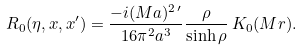<formula> <loc_0><loc_0><loc_500><loc_500>R _ { 0 } ( \eta , { x } , { x ^ { \prime } } ) = \frac { - i ( M a ) ^ { 2 \, \prime } } { 1 6 \pi ^ { 2 } a ^ { 3 } } \frac { \rho } { \sinh \rho } \, K _ { 0 } ( M r ) .</formula> 